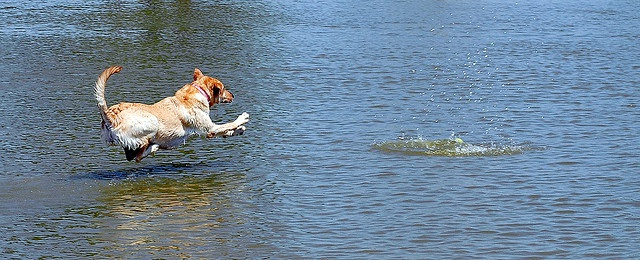Describe the objects in this image and their specific colors. I can see dog in darkgray, ivory, tan, gray, and black tones and sports ball in darkgray, khaki, beige, and lightgreen tones in this image. 